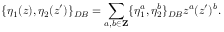Convert formula to latex. <formula><loc_0><loc_0><loc_500><loc_500>\{ \eta _ { 1 } ( z ) , \eta _ { 2 } ( z ^ { \prime } ) \} _ { D B } = \sum _ { a , b \in { Z } } \{ \eta _ { 1 } ^ { a } , \eta _ { 2 } ^ { b } \} _ { D B } z ^ { a } ( z ^ { \prime } ) ^ { b } .</formula> 